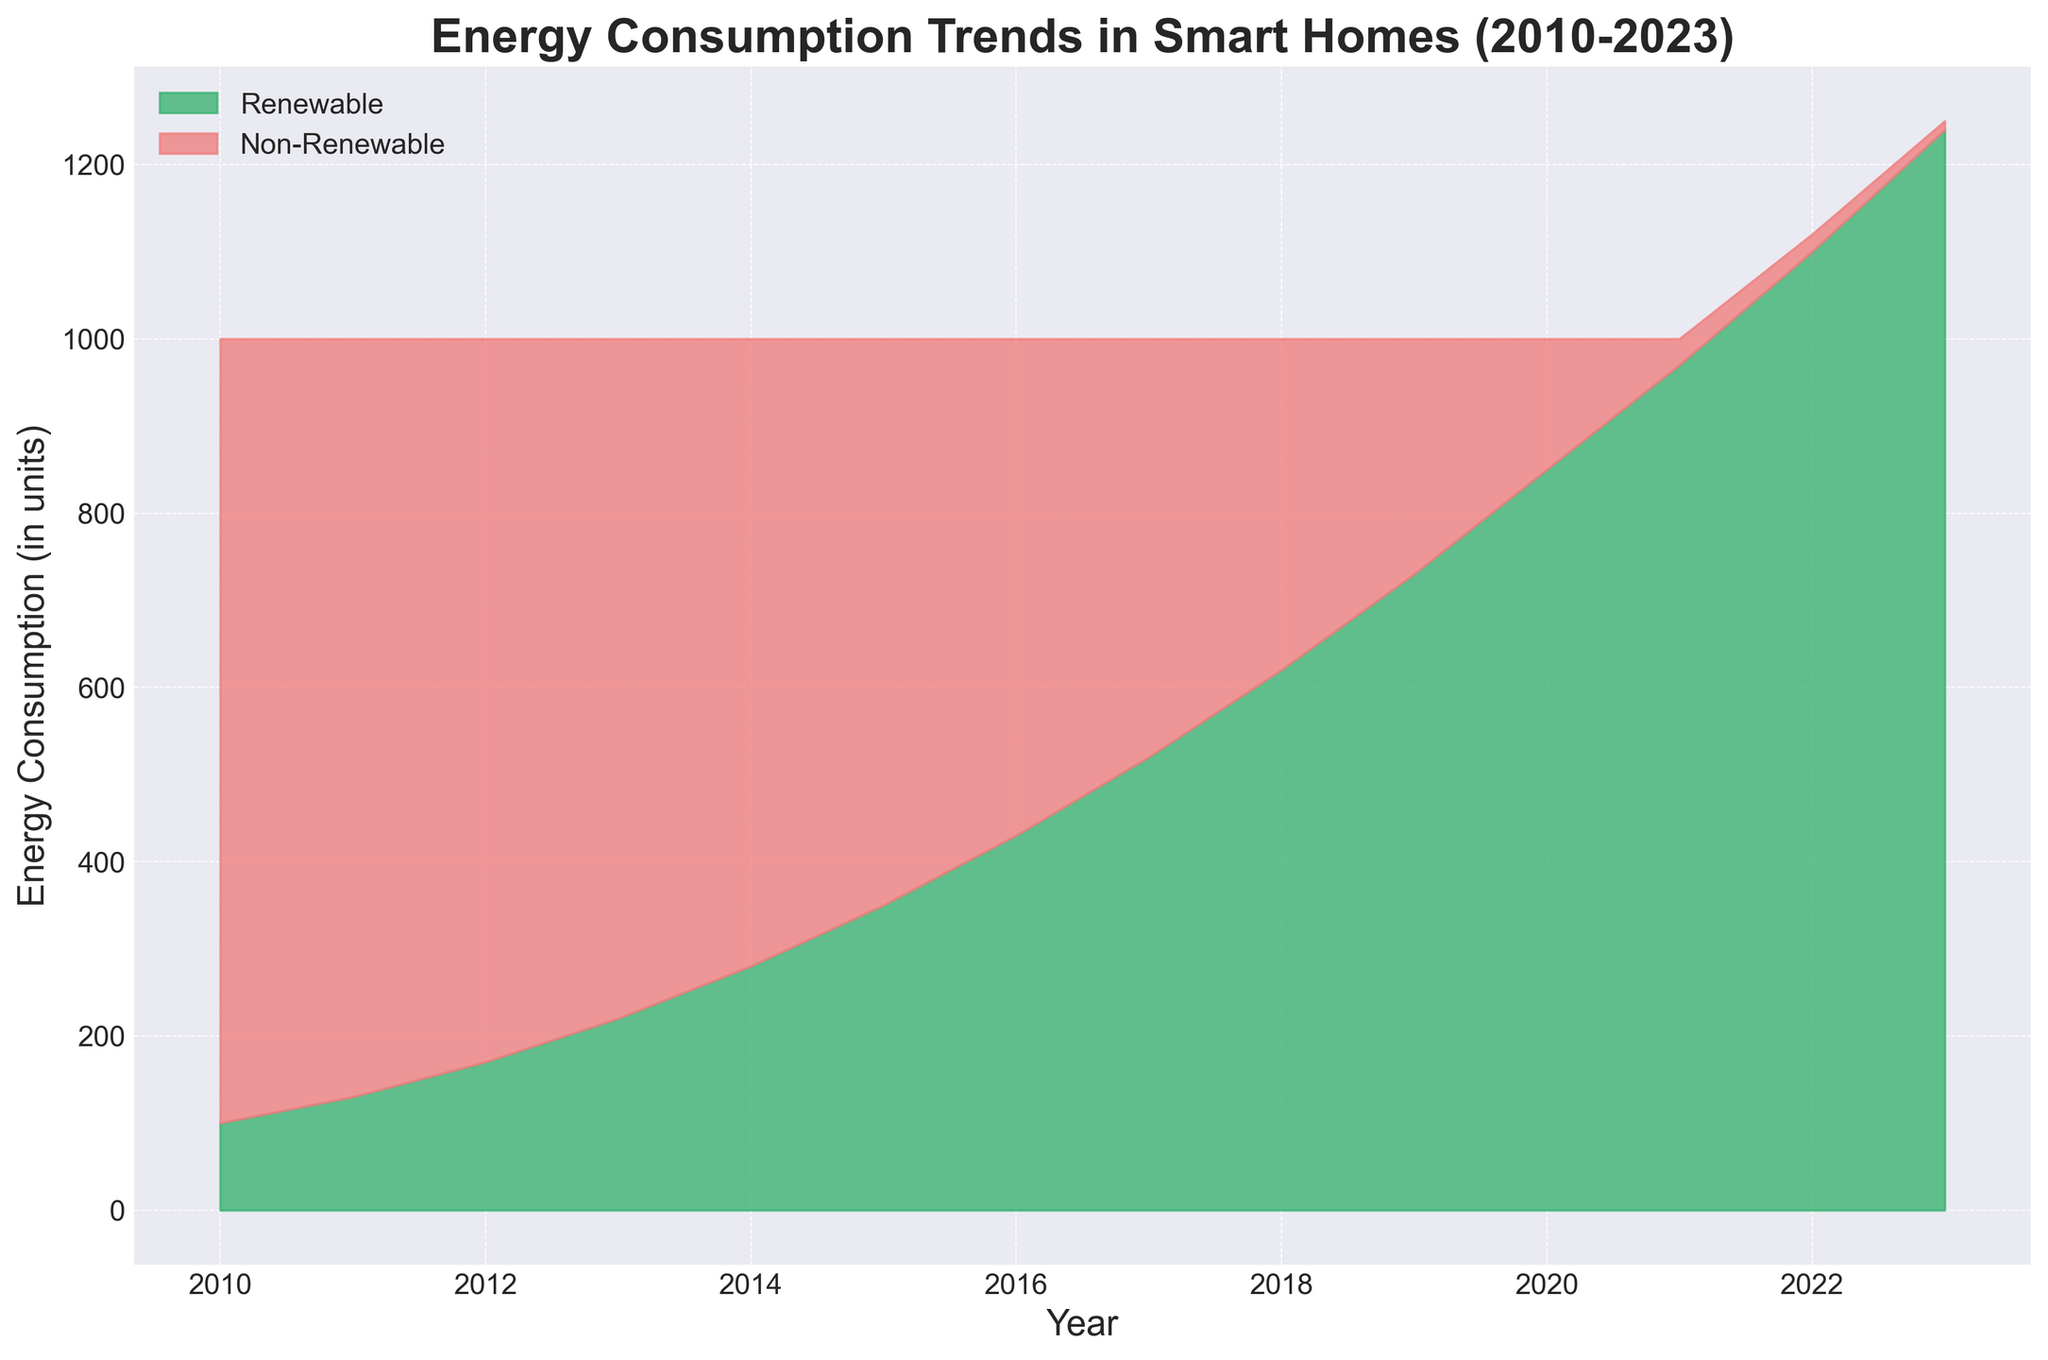What is the trend in renewable energy consumption from 2010 to 2023? Observing the area covered in green from left (2010) to right (2023), we can see it steadily increases in height, indicating a continuous upward trend in renewable energy consumption.
Answer: Upward trend How does non-renewable energy consumption in 2023 compare to 2010? On the rightmost part of the chart (2023), the red area representing non-renewable energy is almost negligible compared to the leftmost part (2010) where it is much larger.
Answer: Decreased significantly In which year did renewable energy consumption surpass non-renewable energy consumption? Find the year where the green area starts being larger than the red area. It clearly happens between 2018 and 2019.
Answer: 2018 What is the combined energy consumption in 2020? Sum the heights of both green and red areas in 2020. Renewable is 850 units and non-renewable is 150 units, summing up to 1000 units.
Answer: 1000 units What visual difference can be observed in energy sources between 2015 and 2021? Compare the green and red areas for both years; in 2015, non-renewable is larger while renewable is smaller, but in 2021, renewable dominates the chart and non-renewable is minimal.
Answer: Renewable dominates by 2021 Which year had the highest non-renewable energy consumption? The tallest point of the red area corresponds to the leftmost part of the chart in 2010.
Answer: 2010 By how many units did renewable energy consumption increase from 2010 to 2023? Subtract the renewable energy in 2010 (100 units) from that in 2023 (1240 units).
Answer: 1140 units What was the approximate ratio of renewable to non-renewable energy consumption in 2012? Divide the renewable value (170 units) by the non-renewable value (830 units).
Answer: ~0.2 How do the trends of renewable and non-renewable energy consumption compare from 2010 to 2023? The green area gradually grows whereas the red area shrinks almost symmetrically, showing an inverse trend.
Answer: Inverse trends 